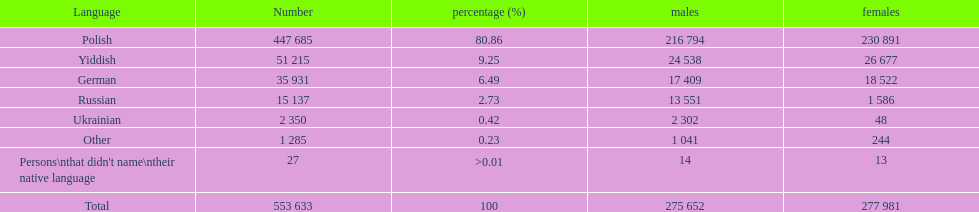Which language was spoken by a mere .42% of the populace in the płock governorate, as per the 1897 imperial census? Ukrainian. 